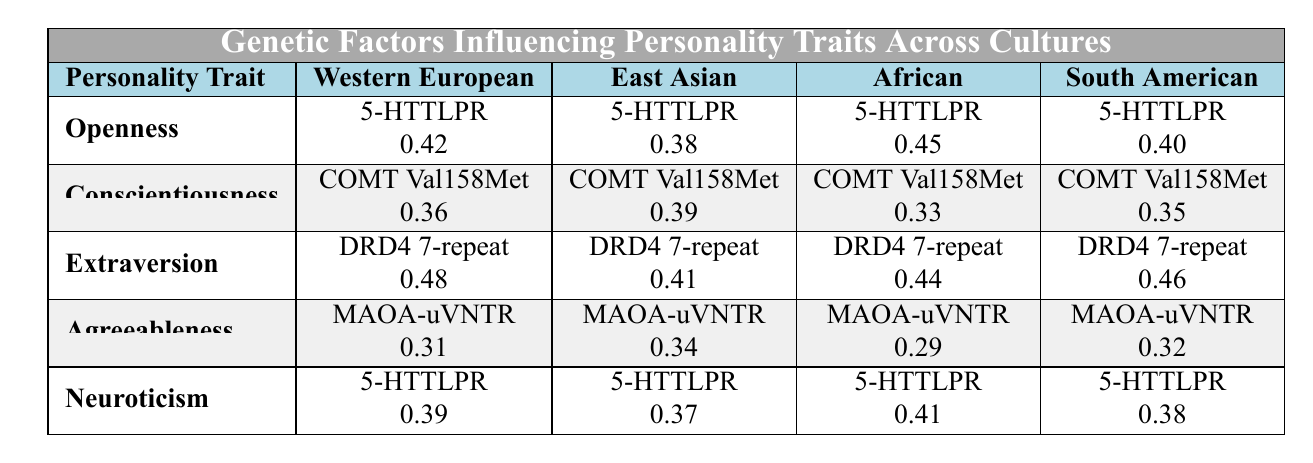What is the influence strength of Openness in the African culture? The table shows that for Openness in the African culture, the genetic factor is 5-HTTLPR, and the influence strength is 0.45.
Answer: 0.45 Which personality trait has the highest influence strength in Western European culture? By looking at the table, Extraversion has the highest influence strength of 0.48 in Western European culture compared to the other traits.
Answer: Extraversion What genetic factor is associated with Agreeableness across all cultures listed? The table indicates that the genetic factor associated with Agreeableness for all cultures is MAOA-uVNTR.
Answer: MAOA-uVNTR Which culture shows the lowest influence strength for Conscientiousness, and what is that value? The lowest influence strength for Conscientiousness is in African culture with a value of 0.33.
Answer: African, 0.33 Is the influence strength of Neuroticism higher in East Asian culture than in South American culture? In East Asian culture, the influence strength for Neuroticism is 0.37, while in South American culture it is 0.38. Since 0.37 is less than 0.38, the statement is false.
Answer: No What is the average influence strength of Extraversion across all cultures? To calculate the average, sum the influence strengths: (0.48 + 0.41 + 0.44 + 0.46) = 1.79. There are 4 cultures, so the average is 1.79 / 4 = 0.4475, which rounds to 0.45.
Answer: 0.45 Which culture has the highest influence strength for the genetic factor 5-HTTLPR influencing Openness? The table indicates that the influence strength for Openness with 5-HTTLPR is 0.45 in African culture, which is the highest among the cultures listed.
Answer: African, 0.45 How does the influence strength of Neuroticism in Western European culture compare to that in East Asian culture? In the table, the influence strength for Neuroticism in Western European culture is 0.39 and in East Asian culture is 0.37. Therefore, Western European culture has a higher influence strength.
Answer: Western European is higher 